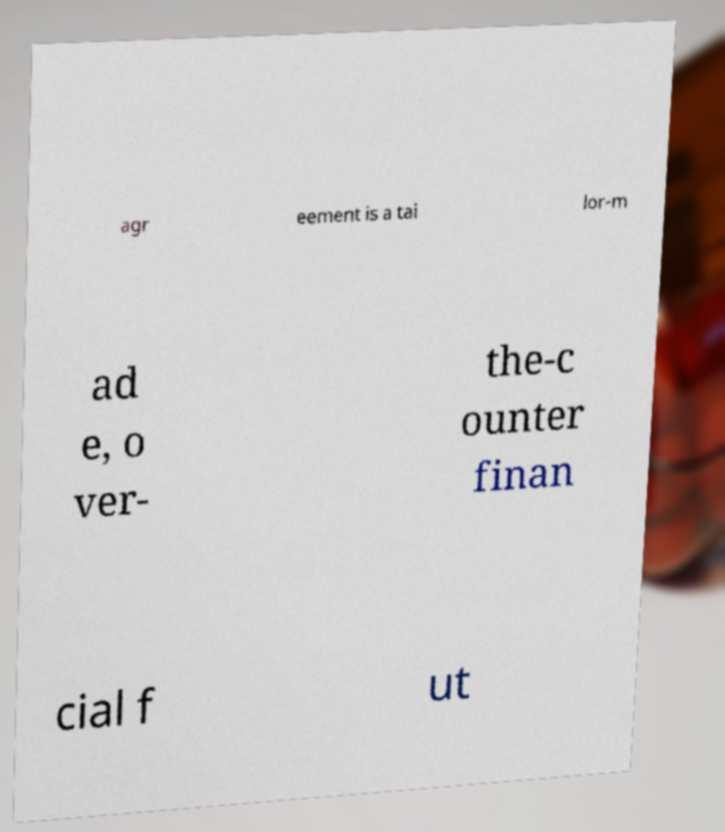Please read and relay the text visible in this image. What does it say? agr eement is a tai lor-m ad e, o ver- the-c ounter finan cial f ut 